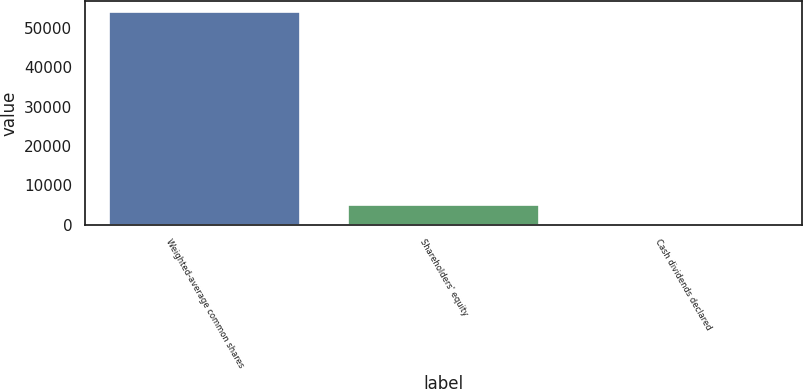<chart> <loc_0><loc_0><loc_500><loc_500><bar_chart><fcel>Weighted-average common shares<fcel>Shareholders' equity<fcel>Cash dividends declared<nl><fcel>54130.3<fcel>5032.44<fcel>0.16<nl></chart> 